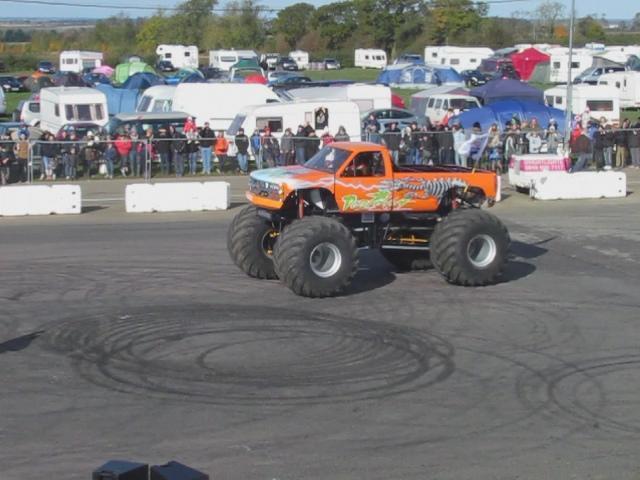How many trucks are there?
Give a very brief answer. 4. 